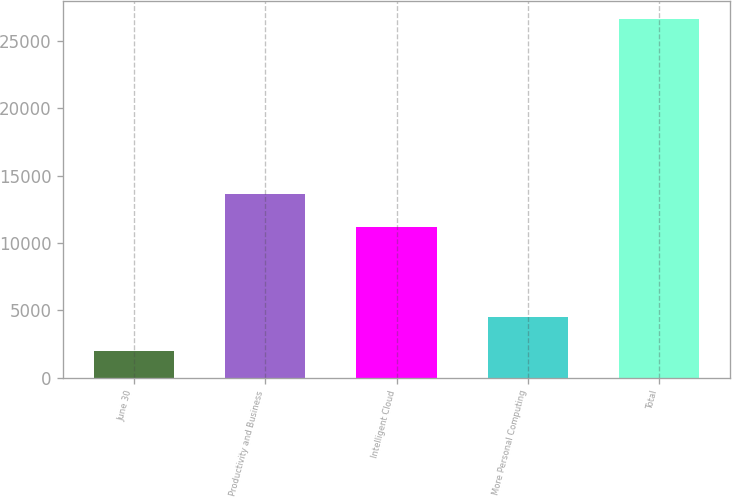Convert chart to OTSL. <chart><loc_0><loc_0><loc_500><loc_500><bar_chart><fcel>June 30<fcel>Productivity and Business<fcel>Intelligent Cloud<fcel>More Personal Computing<fcel>Total<nl><fcel>2017<fcel>13615.9<fcel>11152<fcel>4480.9<fcel>26656<nl></chart> 